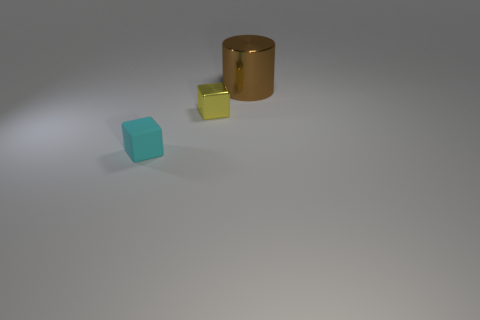Is there anything else that has the same material as the small cyan cube?
Give a very brief answer. No. Are there any other things that are the same shape as the brown metal thing?
Your response must be concise. No. Are there any yellow cubes of the same size as the matte object?
Provide a short and direct response. Yes. There is another cube that is the same size as the yellow block; what material is it?
Provide a succinct answer. Rubber. There is a block behind the tiny block that is in front of the small yellow object; what is its size?
Give a very brief answer. Small. There is a shiny thing in front of the metallic cylinder; is it the same size as the cyan matte cube?
Your response must be concise. Yes. Are there more yellow metallic things in front of the metallic cylinder than small cyan matte blocks in front of the cyan rubber cube?
Provide a succinct answer. Yes. What is the shape of the metallic object that is in front of the big metal object?
Your answer should be compact. Cube. There is a block that is behind the cube that is in front of the metallic object that is on the left side of the large metal cylinder; what size is it?
Your response must be concise. Small. Do the large brown metal object and the tiny cyan thing have the same shape?
Ensure brevity in your answer.  No. 